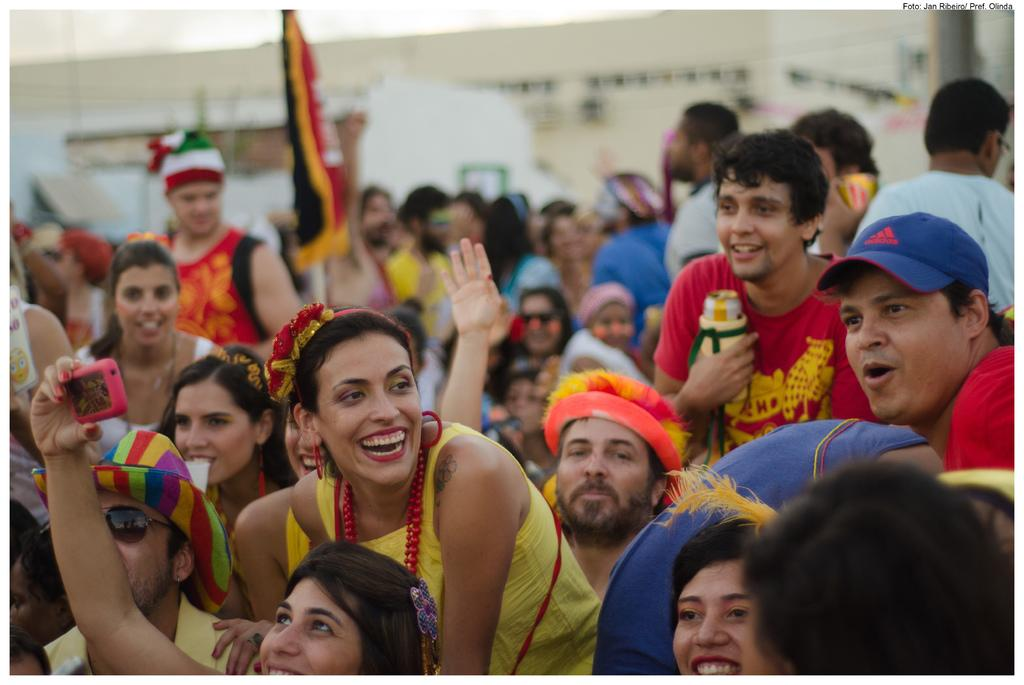What is the main subject of the image? The main subject of the image is a group of people. Can you describe what the people in the group are doing? Some people in the group are holding objects. What additional element can be seen in the image? There is a flag in the image. How would you describe the background of the image? The background of the image is blurred. What type of oatmeal is being served in the image? There is no oatmeal present in the image. Can you tell me how many horses are visible in the image? There are no horses visible in the image. 